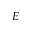Convert formula to latex. <formula><loc_0><loc_0><loc_500><loc_500>E</formula> 